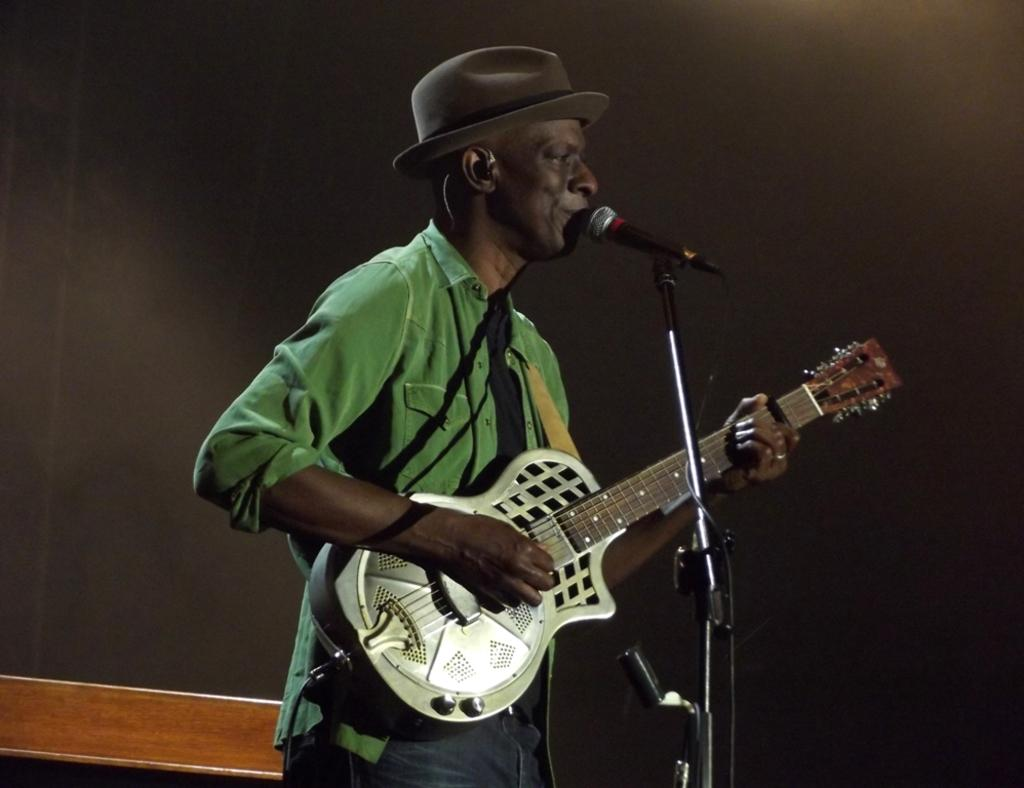What is the person in the image doing? The person is playing the guitar. What is the person wearing in the image? The person is wearing a green shirt. What object is the person holding in the image? The person is holding a guitar. What other object is present in the image? There is a microphone in the image. What type of sweater is the person wearing in the image? The person is not wearing a sweater in the image; they are wearing a green shirt. Can you describe the person's attempt to play the guitar in the image? There is no mention of an attempt in the image; the person is actively playing the guitar. 